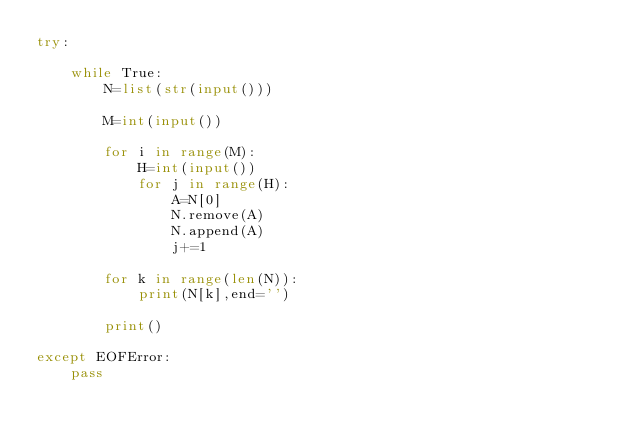Convert code to text. <code><loc_0><loc_0><loc_500><loc_500><_Python_>try:
    
    while True:
        N=list(str(input()))
        
        M=int(input())
    
        for i in range(M):
            H=int(input())
            for j in range(H):
                A=N[0]
                N.remove(A)
                N.append(A)
                j+=1
            
        for k in range(len(N)):  
            print(N[k],end='')
        
        print()
        
except EOFError:
    pass
</code> 